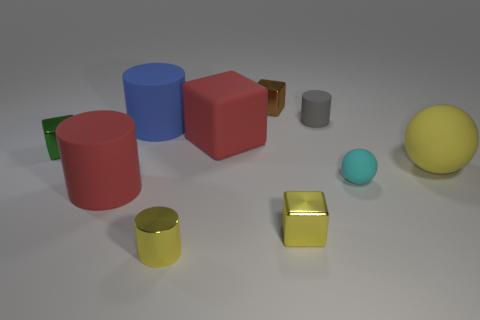What is the size of the yellow sphere that is made of the same material as the red cylinder?
Your answer should be very brief. Large. What number of matte objects are small green cubes or large blocks?
Give a very brief answer. 1. What is the size of the brown thing?
Provide a succinct answer. Small. Is the green shiny cube the same size as the red rubber cylinder?
Make the answer very short. No. There is a large red object that is behind the large yellow matte ball; what is its material?
Offer a terse response. Rubber. What is the material of the big red object that is the same shape as the brown thing?
Provide a short and direct response. Rubber. Is there a tiny gray cylinder to the left of the shiny cube in front of the small cyan sphere?
Your answer should be very brief. No. Is the small green thing the same shape as the blue matte object?
Keep it short and to the point. No. What shape is the brown thing that is made of the same material as the green thing?
Offer a terse response. Cube. There is a red rubber thing that is to the right of the small yellow metallic cylinder; is its size the same as the metal object that is to the left of the tiny yellow metallic cylinder?
Make the answer very short. No. 